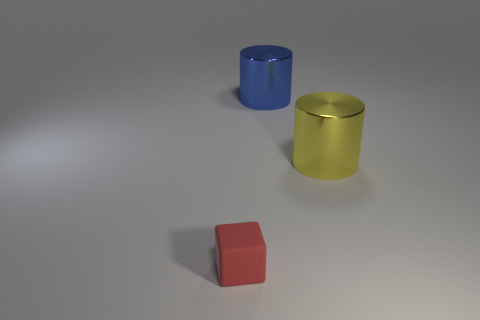Are there fewer yellow shiny objects behind the yellow metal object than small red rubber blocks left of the tiny red cube?
Your response must be concise. No. Are there any large metallic cylinders of the same color as the block?
Give a very brief answer. No. There is a large object in front of the metallic thing that is on the left side of the big cylinder that is to the right of the blue shiny object; what is its shape?
Ensure brevity in your answer.  Cylinder. What is the material of the big cylinder that is on the right side of the blue shiny cylinder?
Make the answer very short. Metal. There is a blue thing behind the big object right of the large shiny cylinder to the left of the yellow metal cylinder; what is its size?
Keep it short and to the point. Large. There is a blue metallic object; is it the same size as the matte block that is in front of the yellow object?
Your answer should be very brief. No. There is a big metallic thing that is to the left of the large yellow shiny thing; what color is it?
Your response must be concise. Blue. There is a blue object that is to the left of the yellow shiny cylinder; what is its shape?
Provide a short and direct response. Cylinder. How many yellow objects are either big shiny cylinders or big rubber things?
Provide a short and direct response. 1. Do the small red block and the large yellow thing have the same material?
Offer a very short reply. No. 